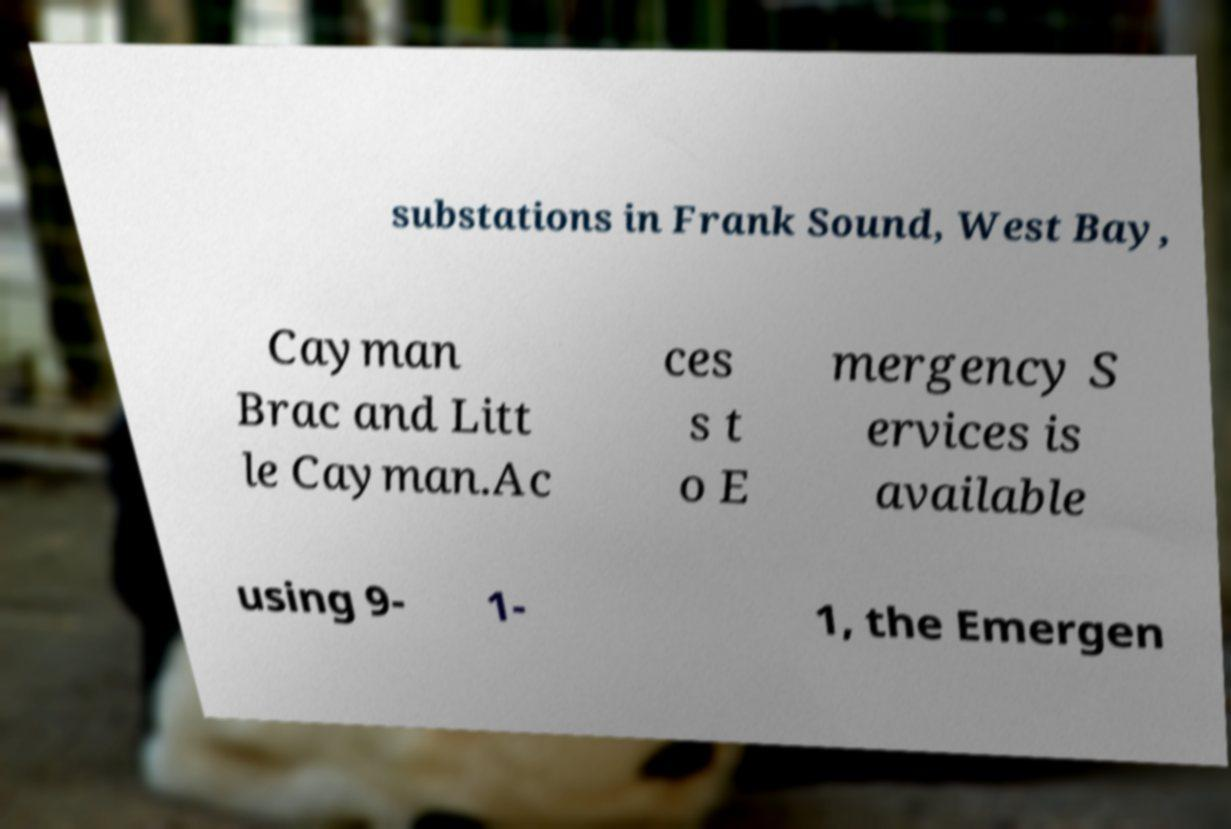There's text embedded in this image that I need extracted. Can you transcribe it verbatim? substations in Frank Sound, West Bay, Cayman Brac and Litt le Cayman.Ac ces s t o E mergency S ervices is available using 9- 1- 1, the Emergen 